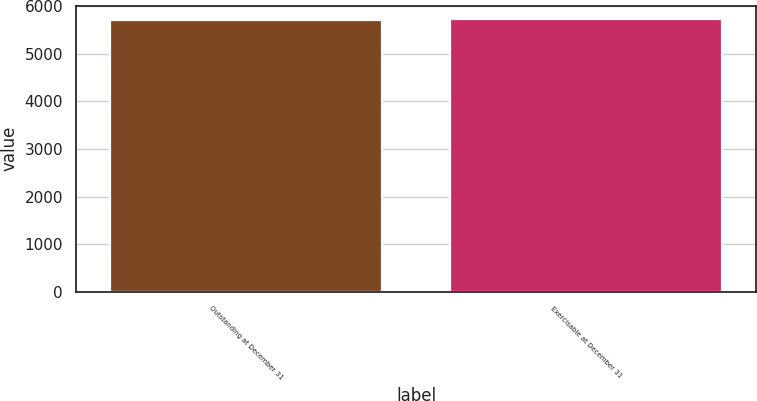Convert chart to OTSL. <chart><loc_0><loc_0><loc_500><loc_500><bar_chart><fcel>Outstanding at December 31<fcel>Exercisable at December 31<nl><fcel>5706<fcel>5726<nl></chart> 